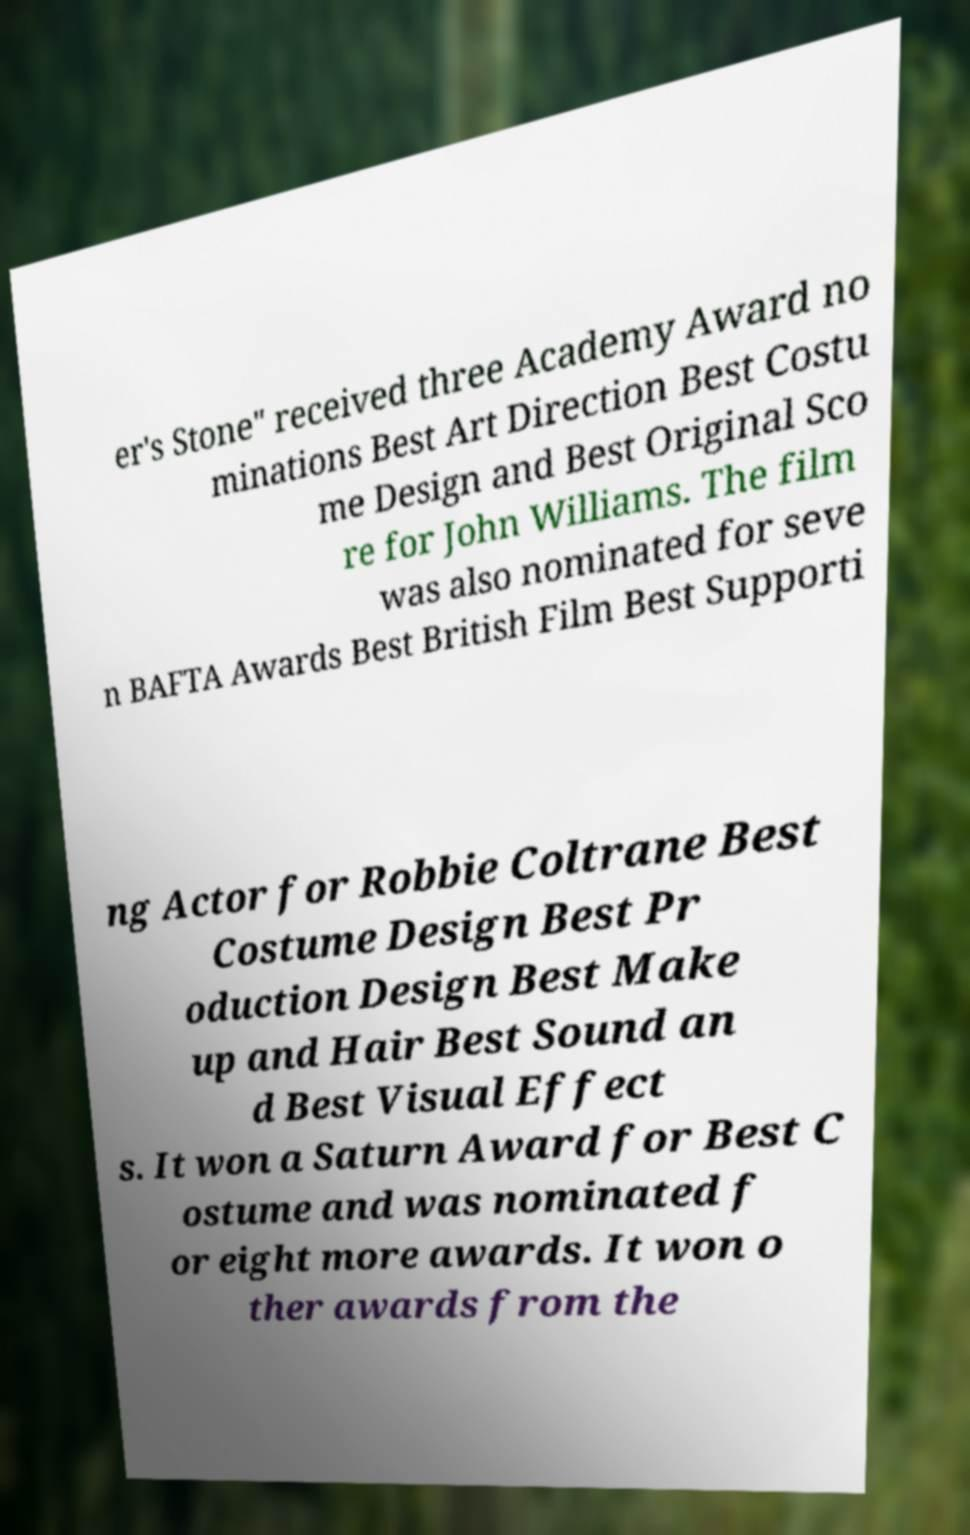I need the written content from this picture converted into text. Can you do that? er's Stone" received three Academy Award no minations Best Art Direction Best Costu me Design and Best Original Sco re for John Williams. The film was also nominated for seve n BAFTA Awards Best British Film Best Supporti ng Actor for Robbie Coltrane Best Costume Design Best Pr oduction Design Best Make up and Hair Best Sound an d Best Visual Effect s. It won a Saturn Award for Best C ostume and was nominated f or eight more awards. It won o ther awards from the 